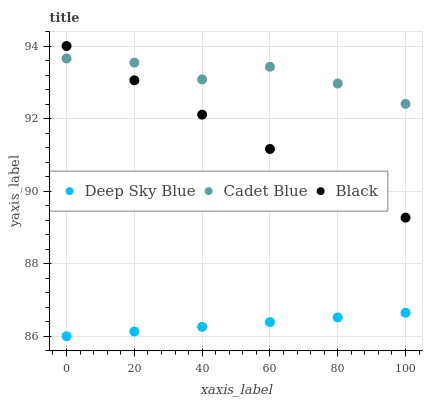Does Deep Sky Blue have the minimum area under the curve?
Answer yes or no. Yes. Does Cadet Blue have the maximum area under the curve?
Answer yes or no. Yes. Does Black have the minimum area under the curve?
Answer yes or no. No. Does Black have the maximum area under the curve?
Answer yes or no. No. Is Black the smoothest?
Answer yes or no. Yes. Is Cadet Blue the roughest?
Answer yes or no. Yes. Is Deep Sky Blue the smoothest?
Answer yes or no. No. Is Deep Sky Blue the roughest?
Answer yes or no. No. Does Deep Sky Blue have the lowest value?
Answer yes or no. Yes. Does Black have the lowest value?
Answer yes or no. No. Does Black have the highest value?
Answer yes or no. Yes. Does Deep Sky Blue have the highest value?
Answer yes or no. No. Is Deep Sky Blue less than Black?
Answer yes or no. Yes. Is Black greater than Deep Sky Blue?
Answer yes or no. Yes. Does Black intersect Cadet Blue?
Answer yes or no. Yes. Is Black less than Cadet Blue?
Answer yes or no. No. Is Black greater than Cadet Blue?
Answer yes or no. No. Does Deep Sky Blue intersect Black?
Answer yes or no. No. 